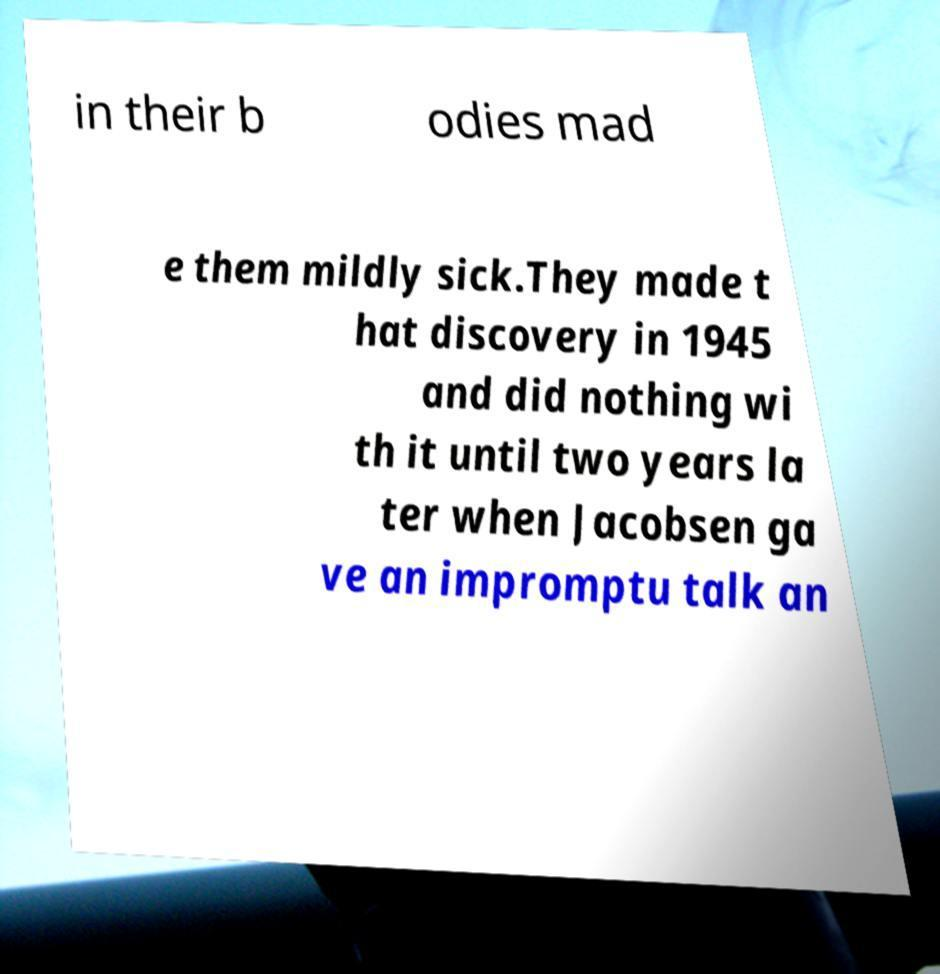Could you extract and type out the text from this image? in their b odies mad e them mildly sick.They made t hat discovery in 1945 and did nothing wi th it until two years la ter when Jacobsen ga ve an impromptu talk an 